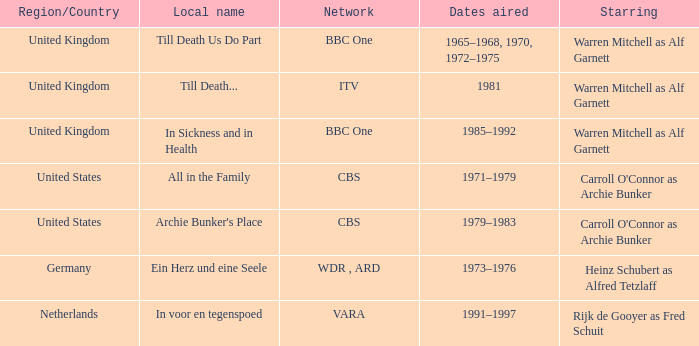Which individual was the leading star on the vara network? Rijk de Gooyer as Fred Schuit. 